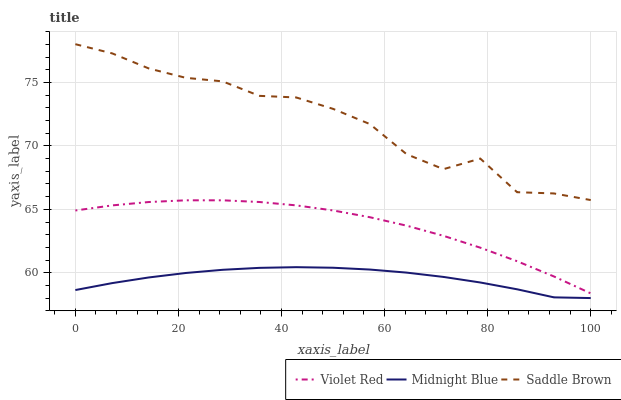Does Midnight Blue have the minimum area under the curve?
Answer yes or no. Yes. Does Saddle Brown have the maximum area under the curve?
Answer yes or no. Yes. Does Saddle Brown have the minimum area under the curve?
Answer yes or no. No. Does Midnight Blue have the maximum area under the curve?
Answer yes or no. No. Is Violet Red the smoothest?
Answer yes or no. Yes. Is Saddle Brown the roughest?
Answer yes or no. Yes. Is Midnight Blue the smoothest?
Answer yes or no. No. Is Midnight Blue the roughest?
Answer yes or no. No. Does Midnight Blue have the lowest value?
Answer yes or no. Yes. Does Saddle Brown have the lowest value?
Answer yes or no. No. Does Saddle Brown have the highest value?
Answer yes or no. Yes. Does Midnight Blue have the highest value?
Answer yes or no. No. Is Midnight Blue less than Saddle Brown?
Answer yes or no. Yes. Is Violet Red greater than Midnight Blue?
Answer yes or no. Yes. Does Midnight Blue intersect Saddle Brown?
Answer yes or no. No. 